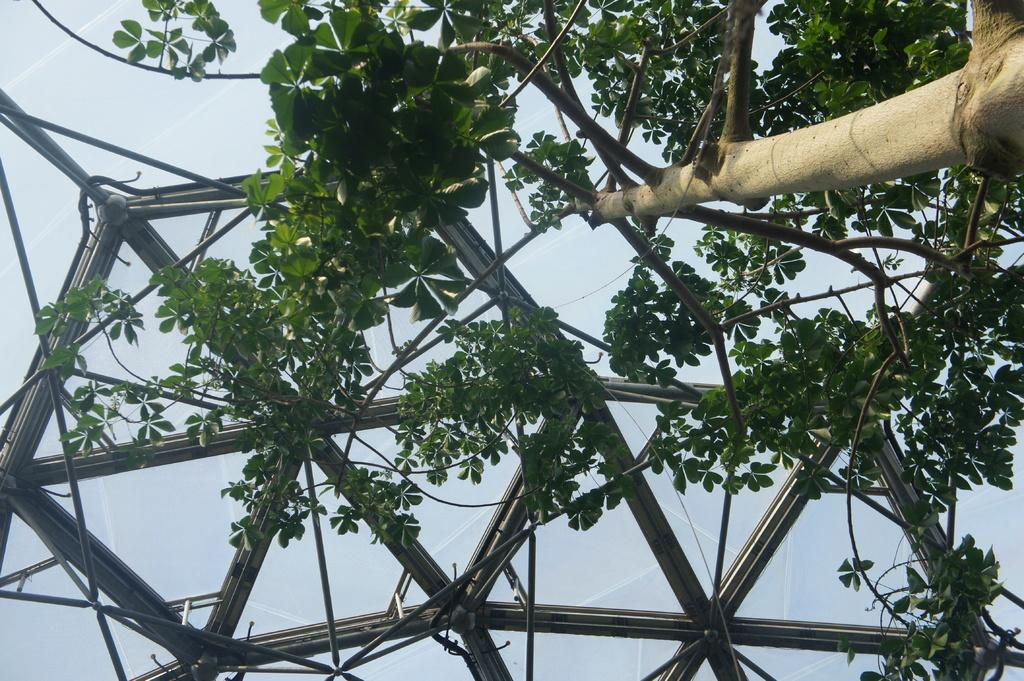What type of vegetation is on the right side of the image? There is a tree on the right side of the image. What structure can be seen in the background of the image? There appears to be a tent in the background of the image. What type of pen is visible in the image? There is no pen present in the image. Is there a cave in the image? No, there is no cave in the image; it features a tree and a tent. 